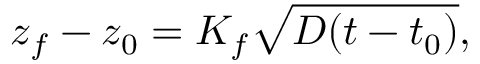Convert formula to latex. <formula><loc_0><loc_0><loc_500><loc_500>z _ { f } - z _ { 0 } = K _ { f } \sqrt { D ( t - t _ { 0 } ) } ,</formula> 